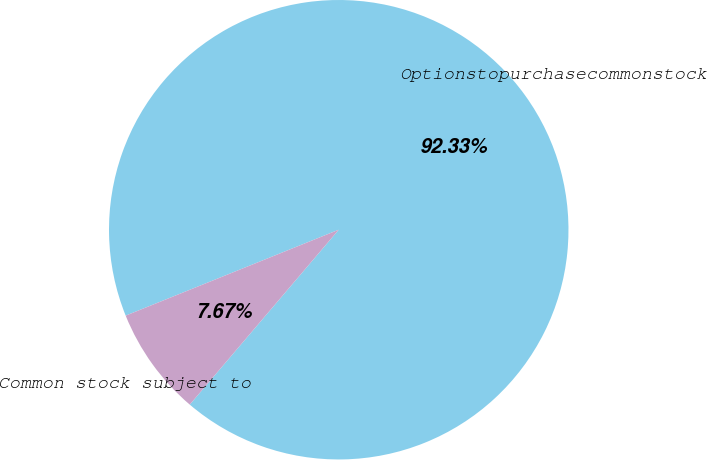Convert chart to OTSL. <chart><loc_0><loc_0><loc_500><loc_500><pie_chart><fcel>Optionstopurchasecommonstock<fcel>Common stock subject to<nl><fcel>92.33%<fcel>7.67%<nl></chart> 